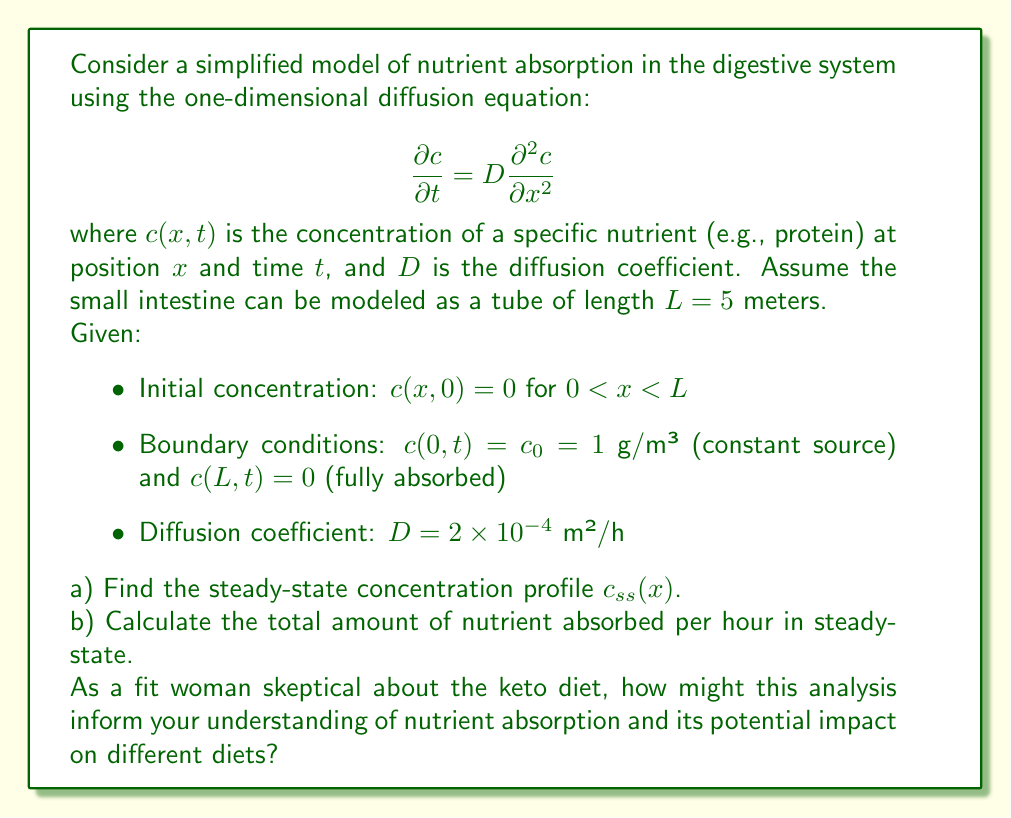Help me with this question. Let's approach this problem step by step:

a) To find the steady-state concentration profile:

1) In steady-state, $\frac{\partial c}{\partial t} = 0$, so the diffusion equation becomes:

   $$0 = D \frac{d^2 c_{ss}}{dx^2}$$

2) Integrating twice:

   $$c_{ss}(x) = Ax + B$$

3) Apply boundary conditions:
   - At $x = 0$: $c_{ss}(0) = c_0 = 1$, so $B = 1$
   - At $x = L$: $c_{ss}(L) = 0$, so $AL + 1 = 0$, or $A = -\frac{1}{L}$

4) Therefore, the steady-state concentration profile is:

   $$c_{ss}(x) = 1 - \frac{x}{L} = 1 - \frac{x}{5}$$

b) To calculate the total amount of nutrient absorbed per hour:

1) The flux of nutrient at any point is given by Fick's law:

   $$J = -D \frac{dc_{ss}}{dx} = -D \left(-\frac{1}{L}\right) = \frac{D}{L}$$

2) Substitute the given values:

   $$J = \frac{2 \times 10^{-4}}{5} = 4 \times 10^{-5} \text{ g/m²/h}$$

3) To get the total amount absorbed, multiply by the surface area. Assuming a cylindrical tube with radius $r = 0.01$ m:

   $$\text{Amount absorbed} = J \cdot 2\pi rL = 4 \times 10^{-5} \cdot 2\pi \cdot 0.01 \cdot 5 = 1.26 \times 10^{-5} \text{ g/h}$$

For a fit woman skeptical about the keto diet, this analysis provides insights into nutrient absorption:

1) The steady-state profile shows that nutrient concentration decreases linearly along the intestine, which is independent of the specific diet.

2) The absorption rate depends on the diffusion coefficient $D$, which can vary for different nutrients. Keto diets, being high in fats, might have different absorption dynamics compared to carbohydrate-rich diets.

3) The model assumes a constant source concentration $c_0$, which may not reflect reality for all diets. Different meal compositions could lead to varying initial concentrations and absorption patterns.

4) While this model provides a basic understanding, it doesn't account for active transport mechanisms or the complex interactions between different nutrients, which are crucial considerations when evaluating different diets.

This analysis emphasizes the importance of considering nutrient absorption dynamics when assessing the effectiveness and health impacts of various diets, including the keto diet.
Answer: a) Steady-state concentration profile: $c_{ss}(x) = 1 - \frac{x}{5}$

b) Total amount of nutrient absorbed per hour in steady-state: $1.26 \times 10^{-5}$ g/h 